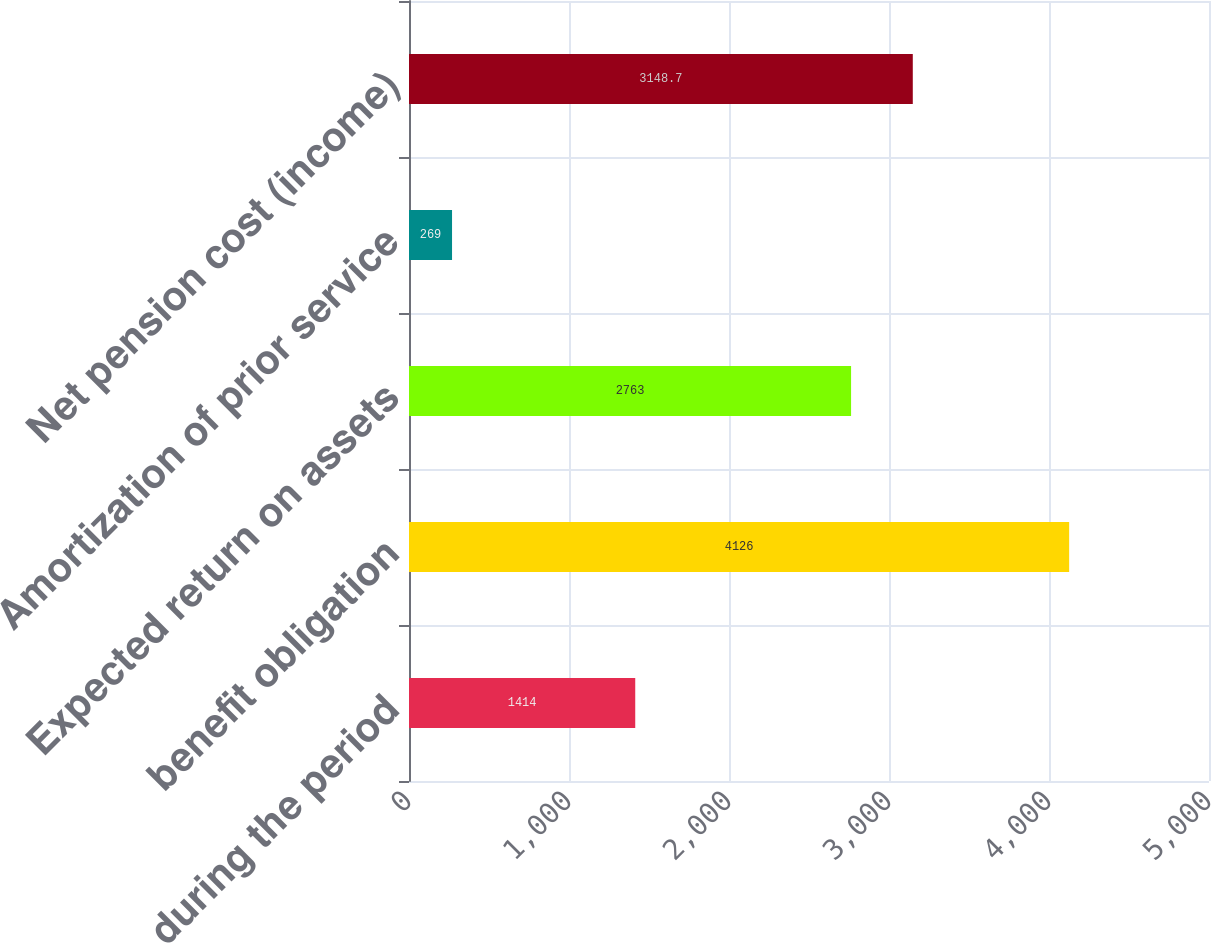Convert chart. <chart><loc_0><loc_0><loc_500><loc_500><bar_chart><fcel>during the period<fcel>benefit obligation<fcel>Expected return on assets<fcel>Amortization of prior service<fcel>Net pension cost (income)<nl><fcel>1414<fcel>4126<fcel>2763<fcel>269<fcel>3148.7<nl></chart> 